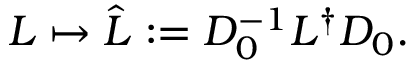<formula> <loc_0><loc_0><loc_500><loc_500>L \mapsto \hat { L } \colon = D _ { 0 } ^ { - 1 } L ^ { \dagger } D _ { 0 } .</formula> 